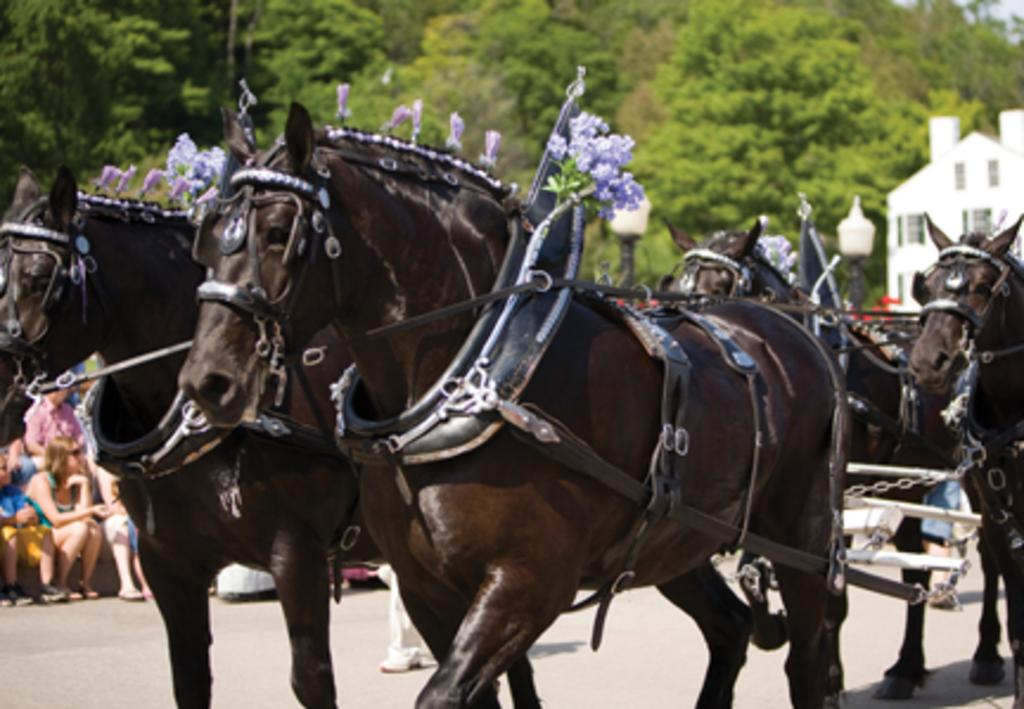What animals can be seen walking in the image? There are horses walking in the image. How are the horses decorated in the image? Flowers are used to decorate the horses. What can be seen in the image besides the horses? There are people sitting and trees present in the image. What type of structure is visible in the image? There is a building with windows in the image. What type of arch can be seen in the image? There is no arch present in the image. What organization is responsible for the event depicted in the image? The image does not depict an event or any organization. 